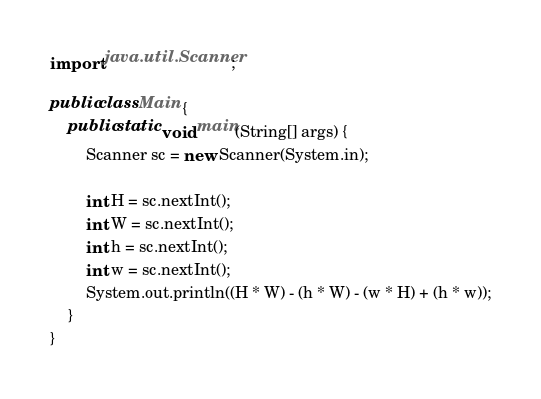Convert code to text. <code><loc_0><loc_0><loc_500><loc_500><_Java_>import java.util.Scanner;

public class Main {
    public static void main(String[] args) {
        Scanner sc = new Scanner(System.in);

        int H = sc.nextInt();
        int W = sc.nextInt();
        int h = sc.nextInt();
        int w = sc.nextInt();
        System.out.println((H * W) - (h * W) - (w * H) + (h * w));
    }
}</code> 